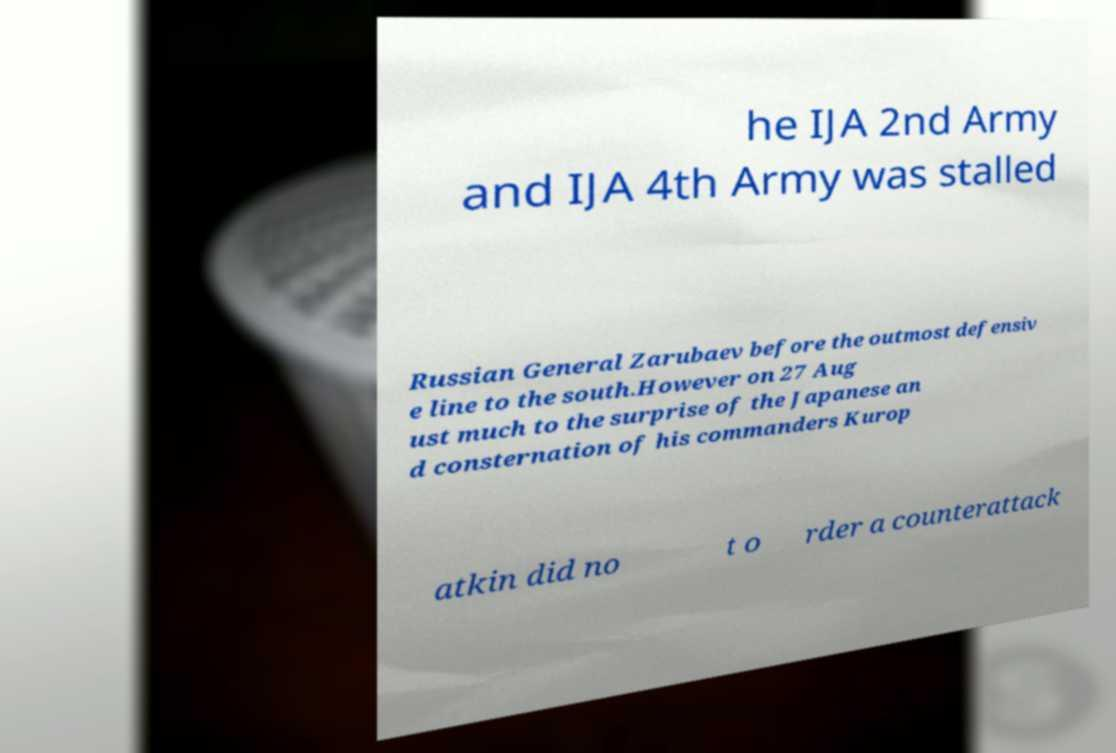For documentation purposes, I need the text within this image transcribed. Could you provide that? he IJA 2nd Army and IJA 4th Army was stalled Russian General Zarubaev before the outmost defensiv e line to the south.However on 27 Aug ust much to the surprise of the Japanese an d consternation of his commanders Kurop atkin did no t o rder a counterattack 